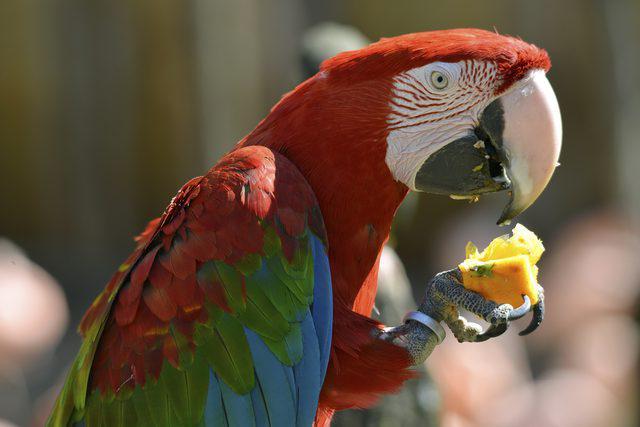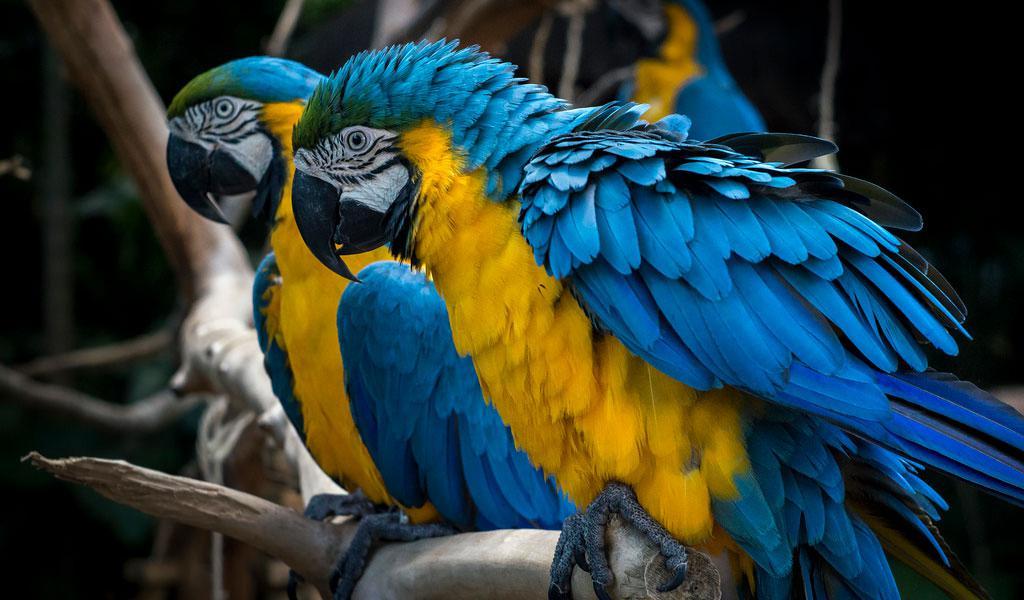The first image is the image on the left, the second image is the image on the right. For the images displayed, is the sentence "There are at least two blue parrots in the right image." factually correct? Answer yes or no. Yes. The first image is the image on the left, the second image is the image on the right. Evaluate the accuracy of this statement regarding the images: "An image contains one red-headed parrot facing rightward, and the other image contains blue-headed birds.". Is it true? Answer yes or no. Yes. 